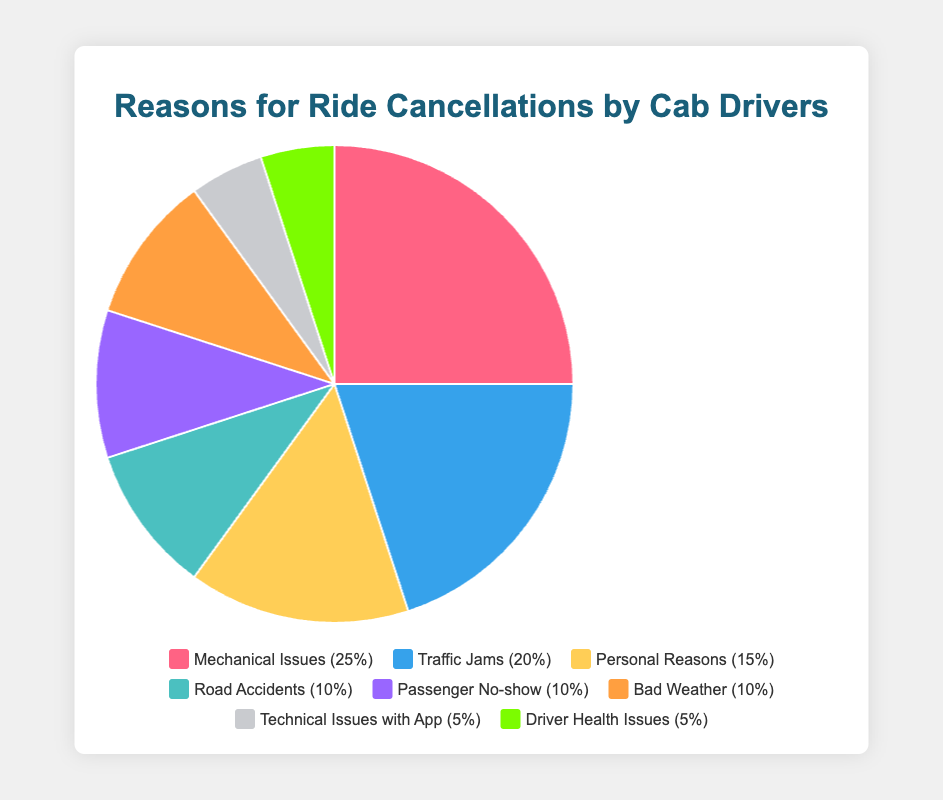What is the most common reason for ride cancellations? The most common reason for ride cancellations can be identified by looking at the slice of the pie chart with the largest percentage. The largest slice corresponds to "Mechanical Issues", which has a 25% share.
Answer: Mechanical Issues Which reason accounts for the smallest percentage of ride cancellations? The smallest percentage can be found by identifying the smallest slice in the pie chart. Both "Technical Issues with App" and "Driver Health Issues" have the smallest slices, representing 5% each.
Answer: Technical Issues with App, Driver Health Issues How much greater is the percentage of cancellations due to Mechanical Issues compared to Traffic Jams? To find how much greater Mechanical Issues (25%) are compared to Traffic Jams (20%), subtract the percentage of Traffic Jams from Mechanical Issues: 25% - 20%.
Answer: 5% What is the combined percentage of ride cancellations due to Road Accidents, Passenger No-show, and Bad Weather? Add the percentages of Road Accidents (10%), Passenger No-show (10%), and Bad Weather (10%) together: 10% + 10% + 10% = 30%.
Answer: 30% Which cancellation reason is represented by a yellow slice in the pie chart? The yellow slice in the pie chart corresponds to "Personal Reasons", which has a 15% share.
Answer: Personal Reasons Are cancellations due to Technical Issues with App and Driver Health Issues equal? Both reasons have the same percentage, each representing 5% of the cancellations.
Answer: Yes What is the difference in percentage between cancellations due to Traffic Jams and Personal Reasons? Subtract the percentage for Personal Reasons (15%) from Traffic Jams (20%): 20% - 15%.
Answer: 5% How do the cancellation percentages of Mechanical Issues and Traffic Jams together compare to the combined percentages of Passenger No-show and Bad Weather? Add the percentages of Mechanical Issues (25%) and Traffic Jams (20%): 25% + 20% = 45%. Then, add the percentages of Passenger No-show (10%) and Bad Weather (10%): 10% + 10% = 20%. Compare the two sums: 45% is greater than 20%.
Answer: Mechanical Issues and Traffic Jams have a greater combined percentage 